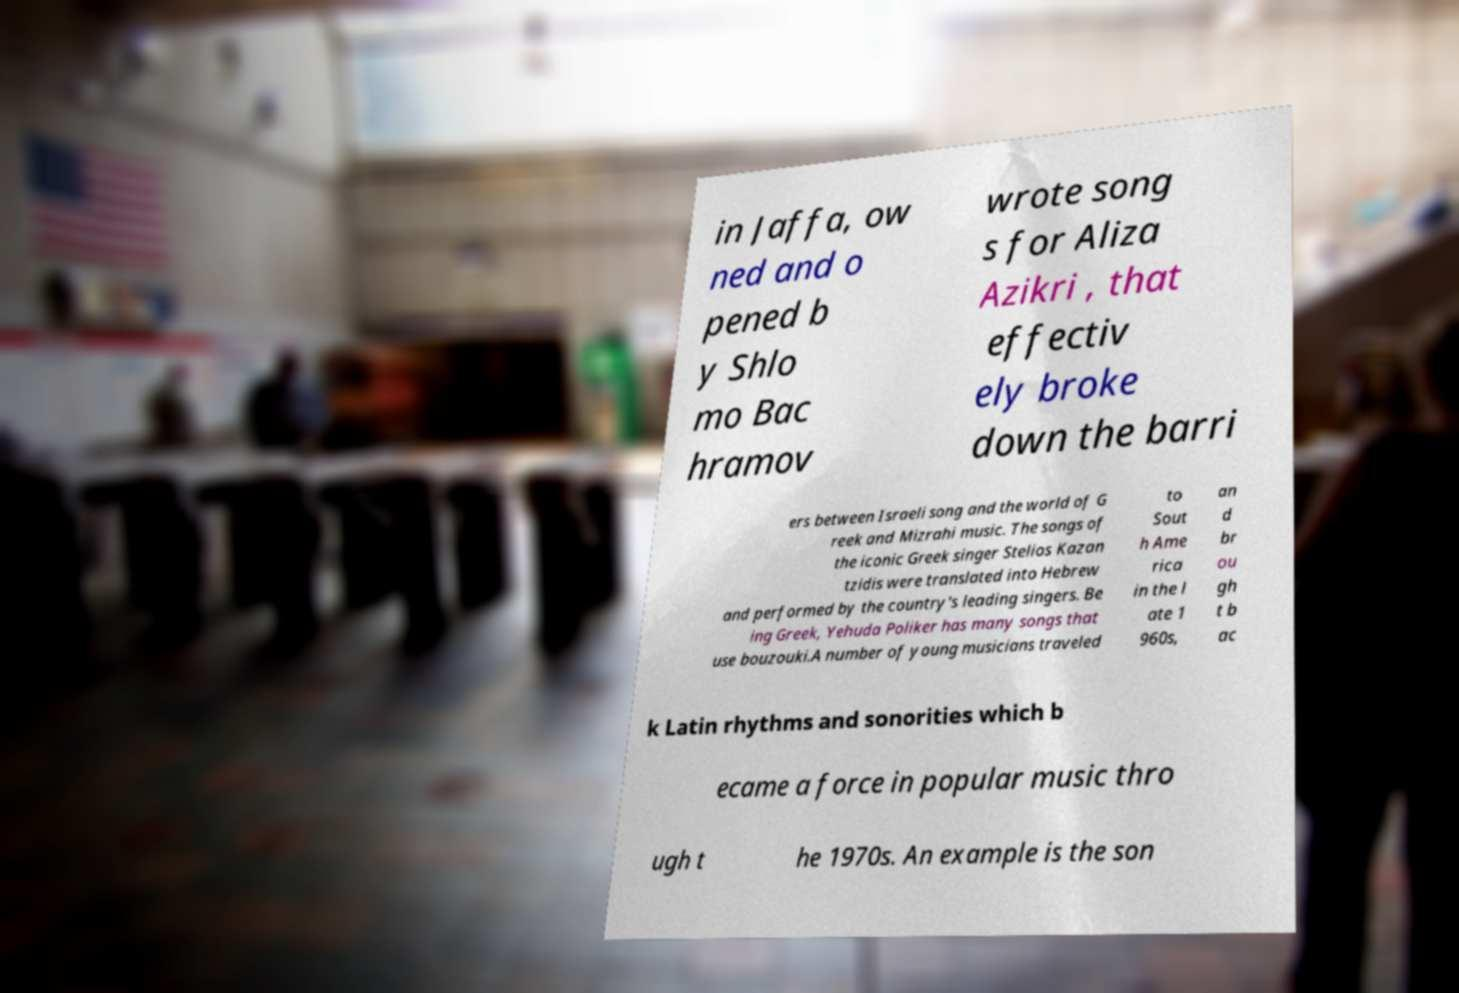I need the written content from this picture converted into text. Can you do that? in Jaffa, ow ned and o pened b y Shlo mo Bac hramov wrote song s for Aliza Azikri , that effectiv ely broke down the barri ers between Israeli song and the world of G reek and Mizrahi music. The songs of the iconic Greek singer Stelios Kazan tzidis were translated into Hebrew and performed by the country's leading singers. Be ing Greek, Yehuda Poliker has many songs that use bouzouki.A number of young musicians traveled to Sout h Ame rica in the l ate 1 960s, an d br ou gh t b ac k Latin rhythms and sonorities which b ecame a force in popular music thro ugh t he 1970s. An example is the son 